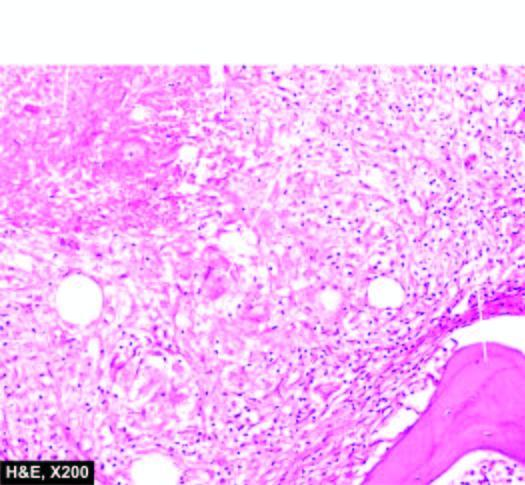re pieces of necrotic bone also seen?
Answer the question using a single word or phrase. Yes 